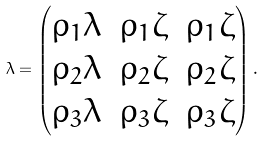<formula> <loc_0><loc_0><loc_500><loc_500>\lambda = \begin{pmatrix} \rho _ { 1 } \lambda & \rho _ { 1 } \zeta & \rho _ { 1 } \zeta \\ \rho _ { 2 } \lambda & \rho _ { 2 } \zeta & \rho _ { 2 } \zeta \\ \rho _ { 3 } \lambda & \rho _ { 3 } \zeta & \rho _ { 3 } \zeta \end{pmatrix} .</formula> 